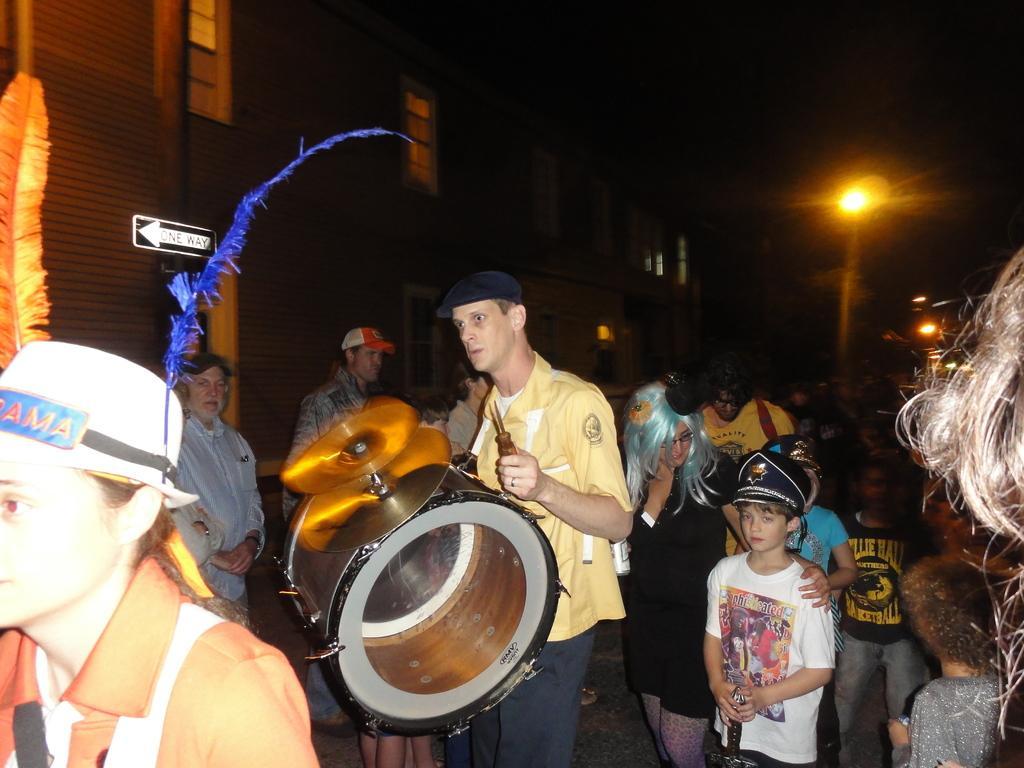Please provide a concise description of this image. In this picture here is the building and here is the window, and a person standing on the road. playing musical drums. here are the group of people and there were children and a women, and here is the person wearing feathers on his head. here is the light and here is the metal rod. 